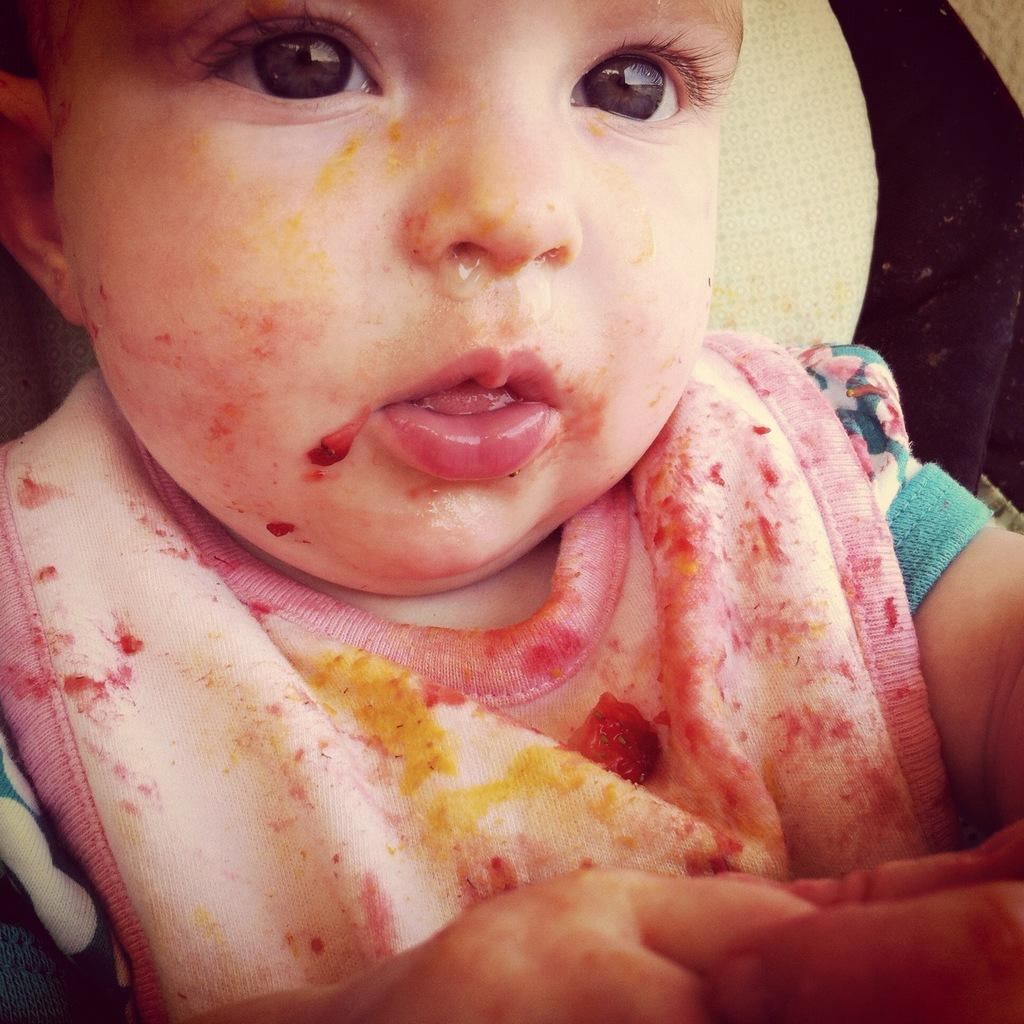What is the main subject of the image? There is a child in the image. How much wealth does the child possess in the image? There is no information about the child's wealth in the image. What type of pie is the child eating in the image? There is no pie present in the image. 